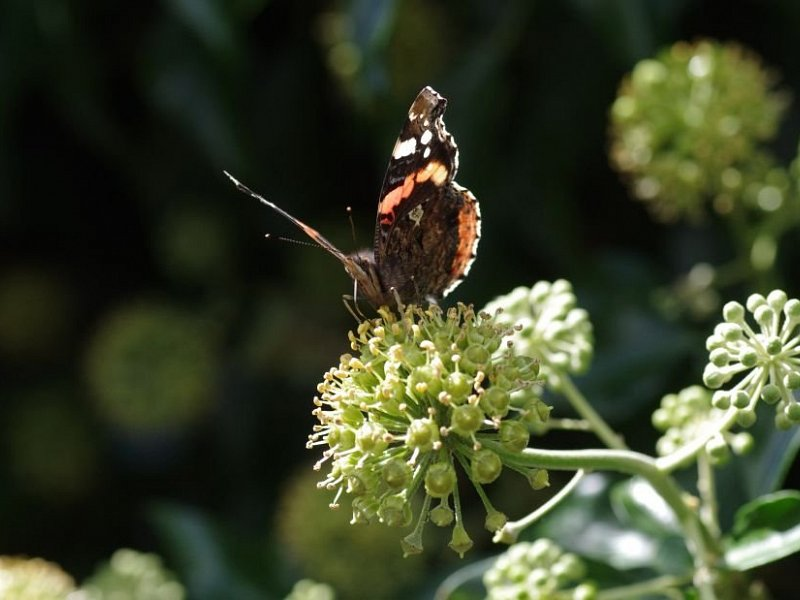Is there any evidence in the image to suggest the current season or geographical location where the photo was taken? The image provides subtle hints about the current season and possible geographical location. The presence of a blooming plant and an active butterfly suggests a warmer season, likely spring or summer, when these conditions are favorable for both plants and insects. Although these elements are common in various regions, the specific type of vegetation and butterfly might give further clues. For instance, if we knew the species of the butterfly or the plant, we could narrow down the geographical location more accurately. Without this specific information, it's challenging to pinpoint an exact location, but the image certainly evokes a setting within a temperate climate zone during a period of warm weather. 